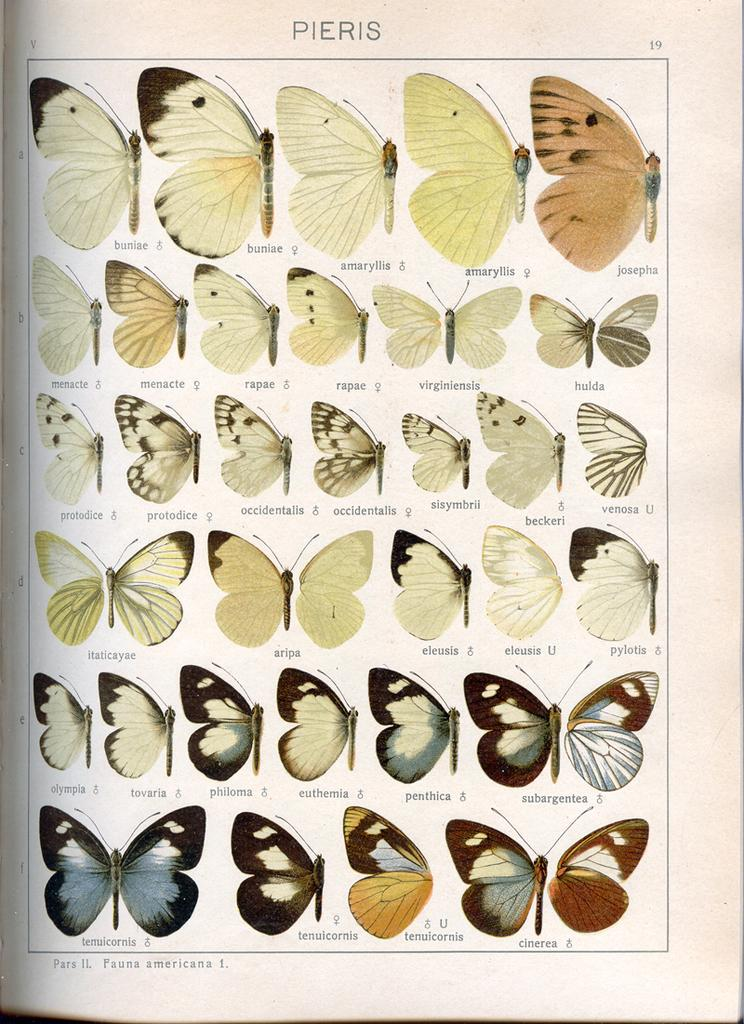What is the main object in the picture? There is a white object in the picture, which appears to be a paper. What can be seen on the paper? The paper contains images of butterflies. Are there any words on the paper? Yes, there is text on the paper. Are there any numbers on the paper? Yes, there are numbers on the paper. What type of honey is being collected by the boys in the image? There are no boys or honey present in the image; it features a paper with butterflies, text, and numbers. 